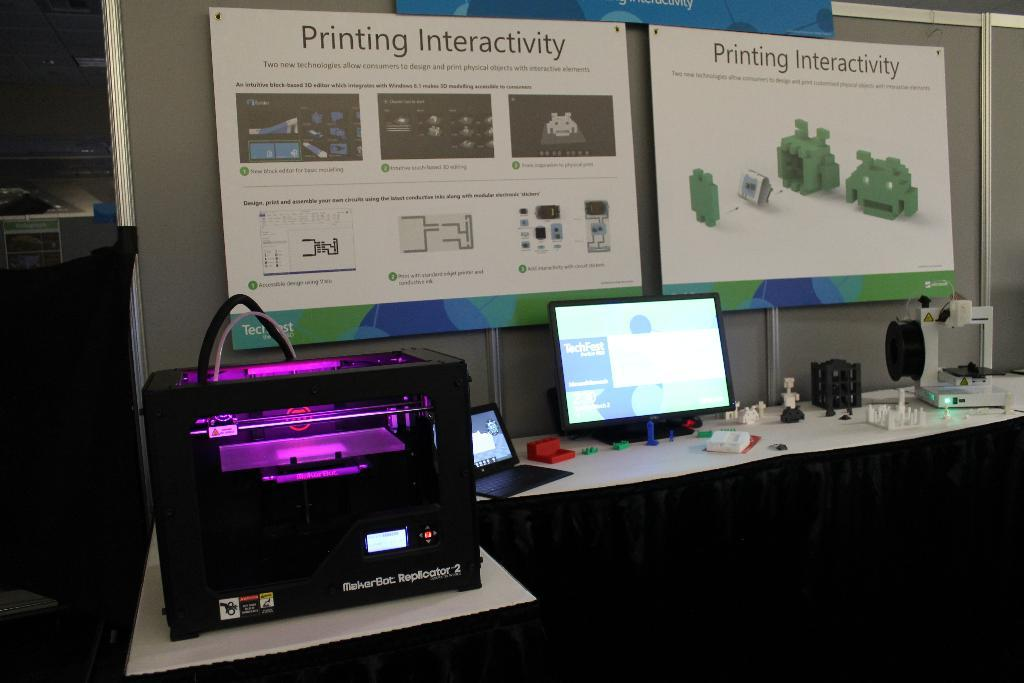<image>
Describe the image concisely. A computer lab that has some displays on the wall commenting on Printing Interactivity. 